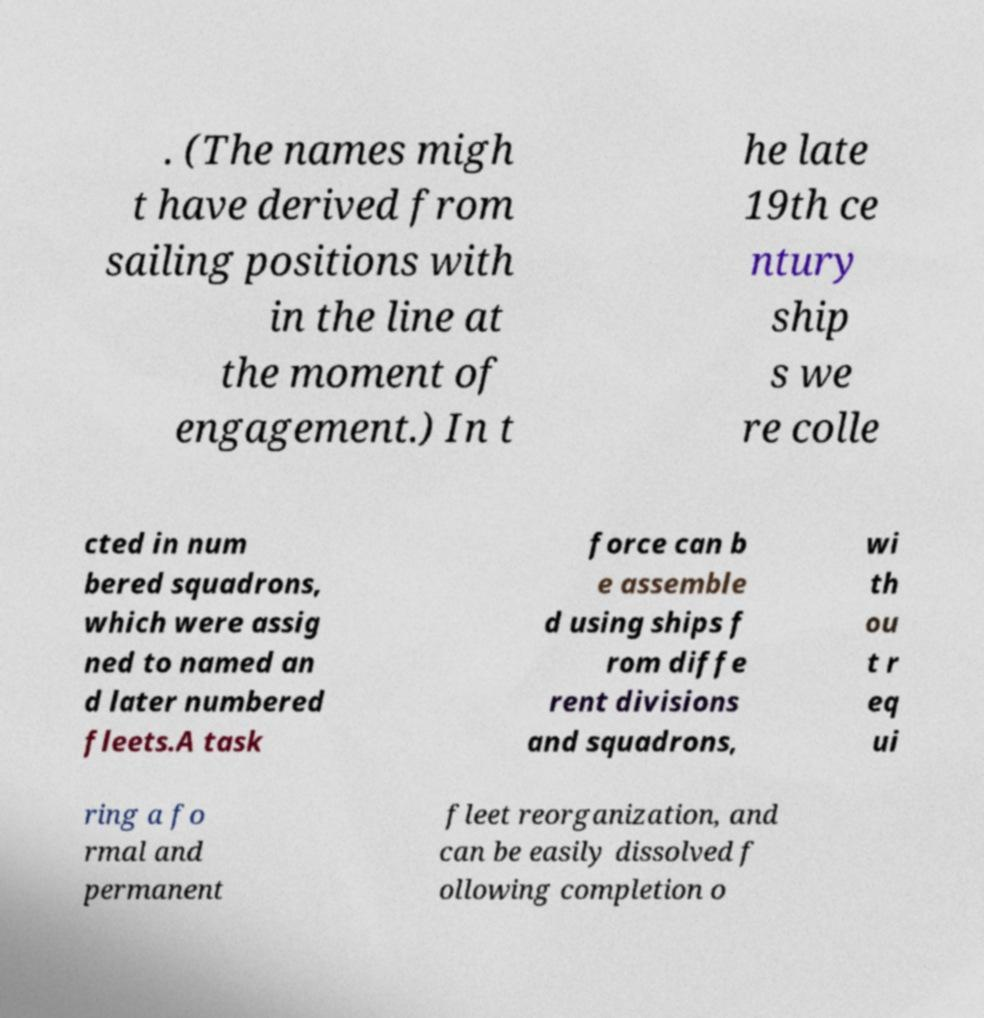Can you accurately transcribe the text from the provided image for me? . (The names migh t have derived from sailing positions with in the line at the moment of engagement.) In t he late 19th ce ntury ship s we re colle cted in num bered squadrons, which were assig ned to named an d later numbered fleets.A task force can b e assemble d using ships f rom diffe rent divisions and squadrons, wi th ou t r eq ui ring a fo rmal and permanent fleet reorganization, and can be easily dissolved f ollowing completion o 